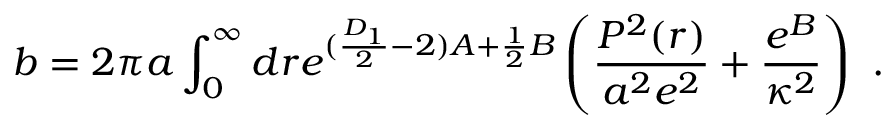<formula> <loc_0><loc_0><loc_500><loc_500>b = 2 \pi a \int _ { 0 } ^ { \infty } d r e ^ { ( \frac { D _ { 1 } } { 2 } - 2 ) A + \frac { 1 } { 2 } B } \left ( \frac { P ^ { 2 } ( r ) } { a ^ { 2 } e ^ { 2 } } + \frac { e ^ { B } } { \kappa ^ { 2 } } \right ) .</formula> 